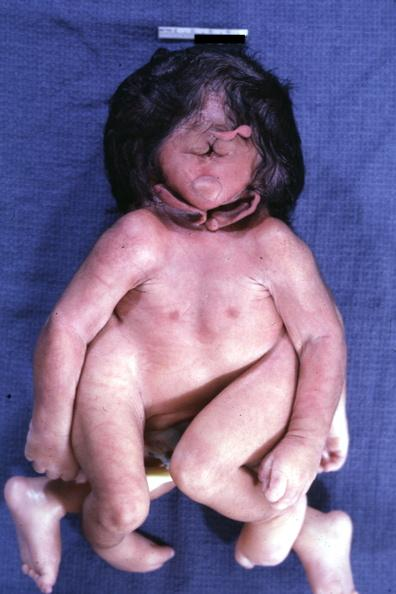s cephalothoracopagus janiceps present?
Answer the question using a single word or phrase. Yes 